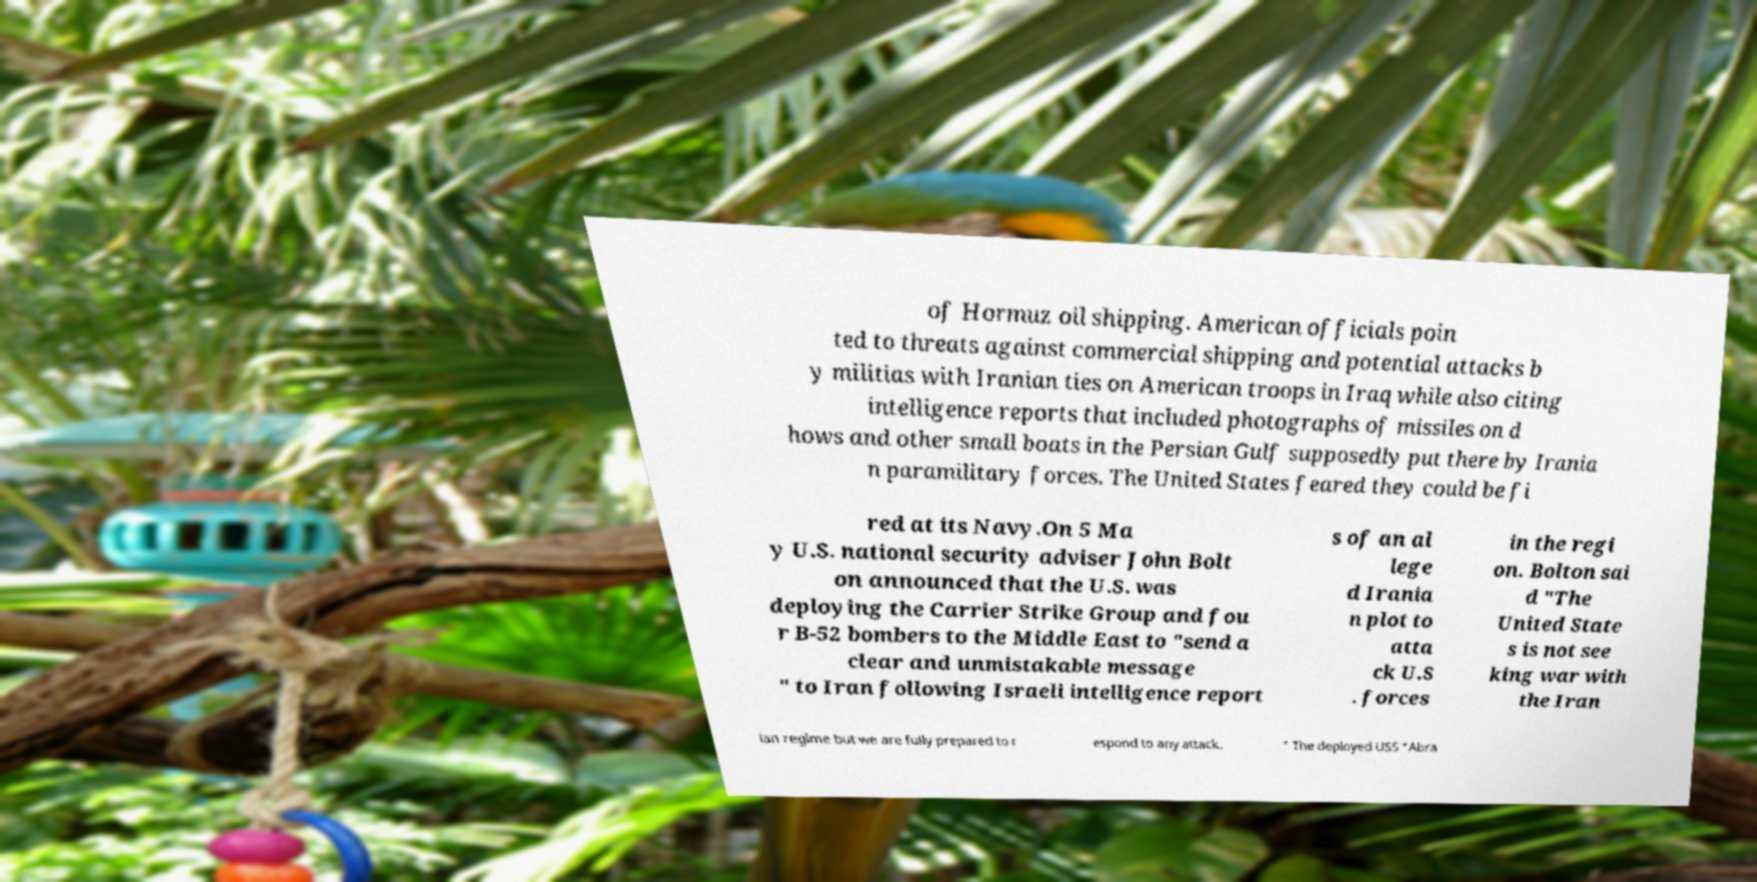Please read and relay the text visible in this image. What does it say? of Hormuz oil shipping. American officials poin ted to threats against commercial shipping and potential attacks b y militias with Iranian ties on American troops in Iraq while also citing intelligence reports that included photographs of missiles on d hows and other small boats in the Persian Gulf supposedly put there by Irania n paramilitary forces. The United States feared they could be fi red at its Navy.On 5 Ma y U.S. national security adviser John Bolt on announced that the U.S. was deploying the Carrier Strike Group and fou r B-52 bombers to the Middle East to "send a clear and unmistakable message " to Iran following Israeli intelligence report s of an al lege d Irania n plot to atta ck U.S . forces in the regi on. Bolton sai d "The United State s is not see king war with the Iran ian regime but we are fully prepared to r espond to any attack. " The deployed USS "Abra 